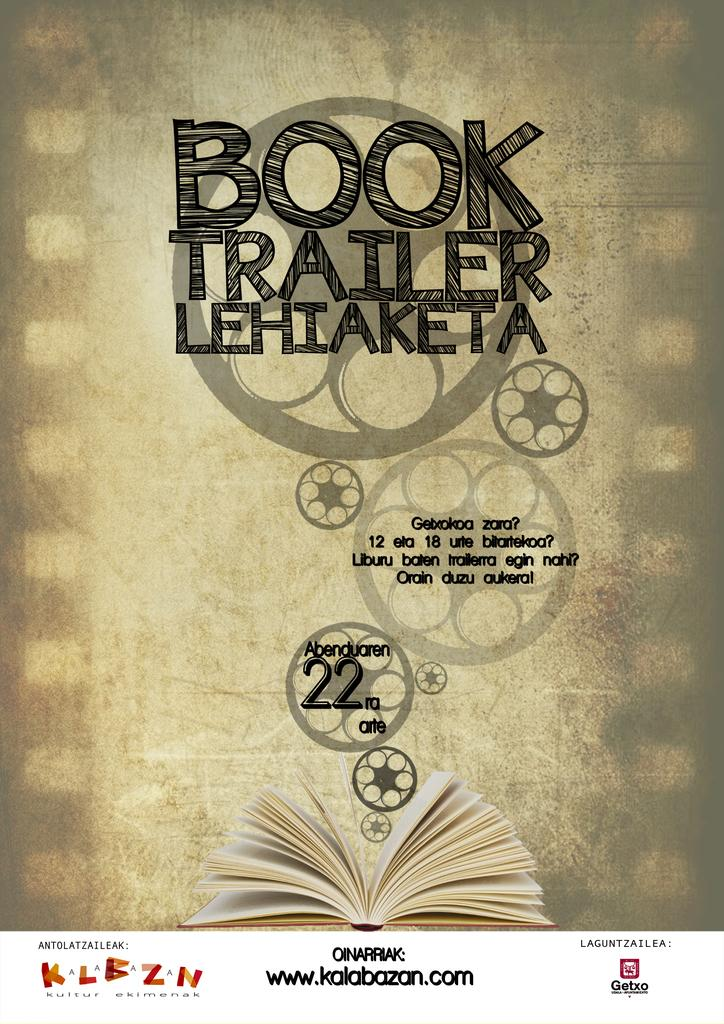<image>
Render a clear and concise summary of the photo. Poster for Book Trailer Lehiaketa with the number 22 on it. 